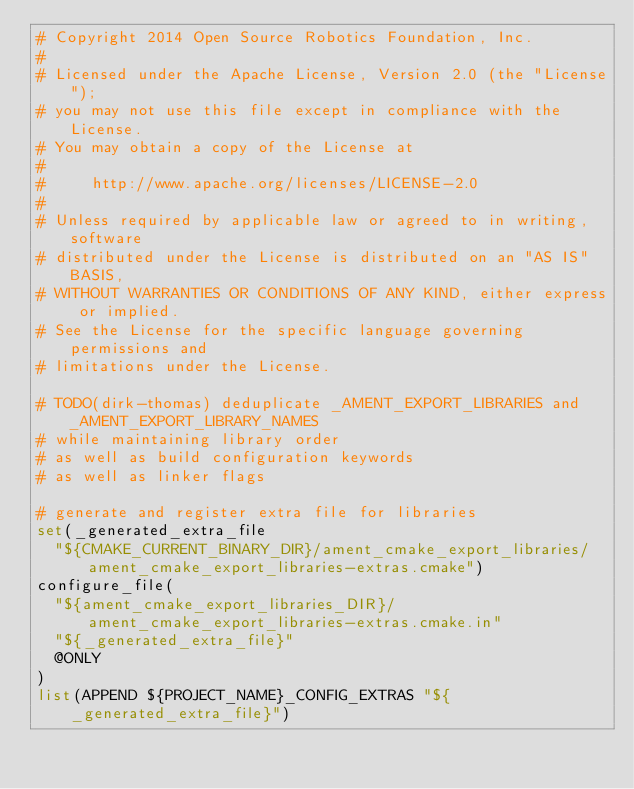<code> <loc_0><loc_0><loc_500><loc_500><_CMake_># Copyright 2014 Open Source Robotics Foundation, Inc.
#
# Licensed under the Apache License, Version 2.0 (the "License");
# you may not use this file except in compliance with the License.
# You may obtain a copy of the License at
#
#     http://www.apache.org/licenses/LICENSE-2.0
#
# Unless required by applicable law or agreed to in writing, software
# distributed under the License is distributed on an "AS IS" BASIS,
# WITHOUT WARRANTIES OR CONDITIONS OF ANY KIND, either express or implied.
# See the License for the specific language governing permissions and
# limitations under the License.

# TODO(dirk-thomas) deduplicate _AMENT_EXPORT_LIBRARIES and _AMENT_EXPORT_LIBRARY_NAMES
# while maintaining library order
# as well as build configuration keywords
# as well as linker flags

# generate and register extra file for libraries
set(_generated_extra_file
  "${CMAKE_CURRENT_BINARY_DIR}/ament_cmake_export_libraries/ament_cmake_export_libraries-extras.cmake")
configure_file(
  "${ament_cmake_export_libraries_DIR}/ament_cmake_export_libraries-extras.cmake.in"
  "${_generated_extra_file}"
  @ONLY
)
list(APPEND ${PROJECT_NAME}_CONFIG_EXTRAS "${_generated_extra_file}")
</code> 